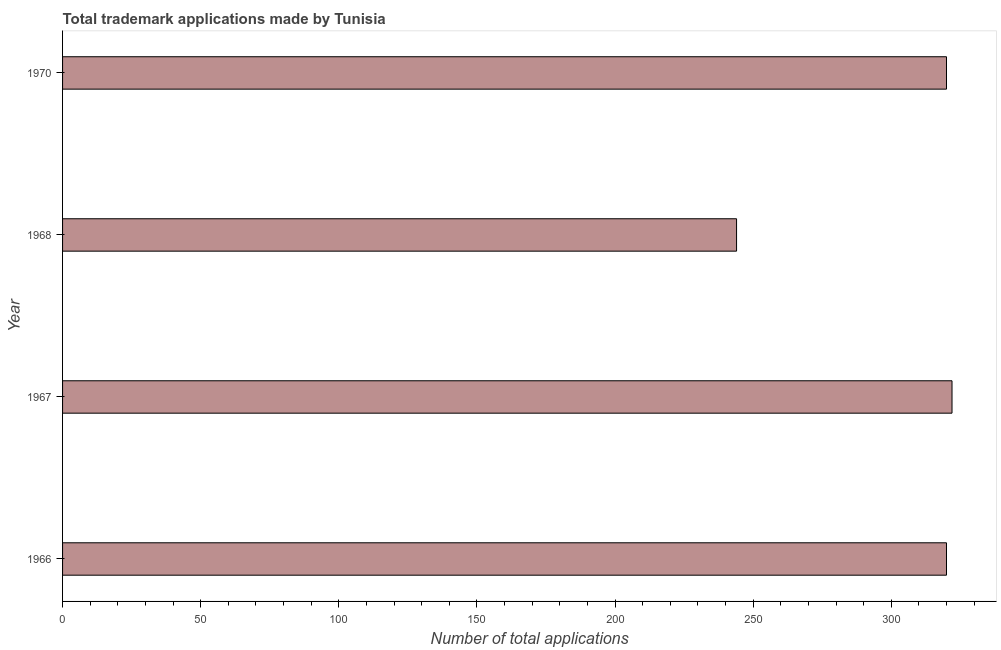Does the graph contain any zero values?
Keep it short and to the point. No. What is the title of the graph?
Keep it short and to the point. Total trademark applications made by Tunisia. What is the label or title of the X-axis?
Keep it short and to the point. Number of total applications. What is the number of trademark applications in 1966?
Give a very brief answer. 320. Across all years, what is the maximum number of trademark applications?
Keep it short and to the point. 322. Across all years, what is the minimum number of trademark applications?
Provide a succinct answer. 244. In which year was the number of trademark applications maximum?
Your answer should be compact. 1967. In which year was the number of trademark applications minimum?
Your response must be concise. 1968. What is the sum of the number of trademark applications?
Offer a very short reply. 1206. What is the average number of trademark applications per year?
Keep it short and to the point. 301. What is the median number of trademark applications?
Make the answer very short. 320. In how many years, is the number of trademark applications greater than 190 ?
Offer a very short reply. 4. Do a majority of the years between 1966 and 1968 (inclusive) have number of trademark applications greater than 190 ?
Offer a very short reply. Yes. Is the difference between the number of trademark applications in 1966 and 1967 greater than the difference between any two years?
Keep it short and to the point. No. In how many years, is the number of trademark applications greater than the average number of trademark applications taken over all years?
Provide a short and direct response. 3. Are all the bars in the graph horizontal?
Offer a terse response. Yes. What is the Number of total applications of 1966?
Keep it short and to the point. 320. What is the Number of total applications of 1967?
Provide a succinct answer. 322. What is the Number of total applications of 1968?
Make the answer very short. 244. What is the Number of total applications of 1970?
Your response must be concise. 320. What is the difference between the Number of total applications in 1966 and 1968?
Offer a terse response. 76. What is the difference between the Number of total applications in 1966 and 1970?
Ensure brevity in your answer.  0. What is the difference between the Number of total applications in 1968 and 1970?
Offer a terse response. -76. What is the ratio of the Number of total applications in 1966 to that in 1968?
Your answer should be compact. 1.31. What is the ratio of the Number of total applications in 1966 to that in 1970?
Provide a succinct answer. 1. What is the ratio of the Number of total applications in 1967 to that in 1968?
Make the answer very short. 1.32. What is the ratio of the Number of total applications in 1967 to that in 1970?
Offer a terse response. 1.01. What is the ratio of the Number of total applications in 1968 to that in 1970?
Give a very brief answer. 0.76. 